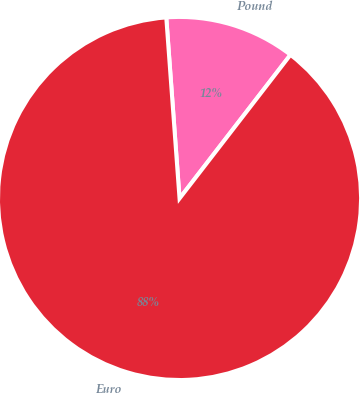<chart> <loc_0><loc_0><loc_500><loc_500><pie_chart><fcel>Pound<fcel>Euro<nl><fcel>11.63%<fcel>88.37%<nl></chart> 